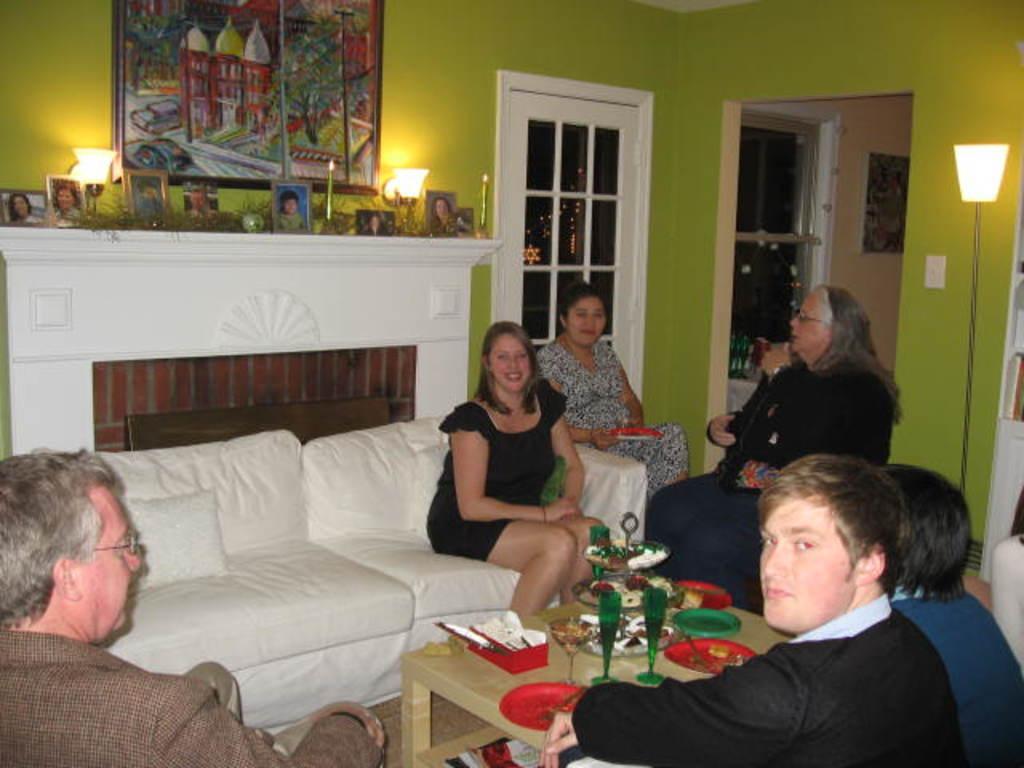Can you describe this image briefly? There are many people sitting in this room. There is a table in the middle on which some food items, glasses and plates were placed on it. There are men and women in this group. In the background there is a photo frame attached to the wall and a door here. 